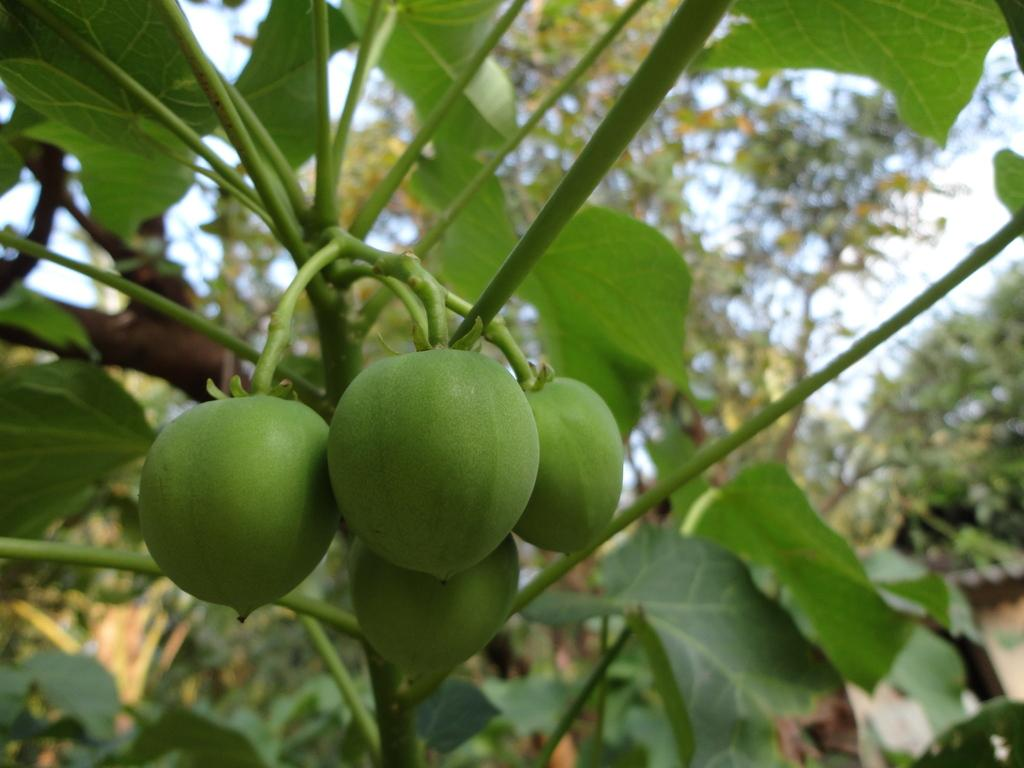What type of living organisms can be seen on the plant in the image? There are fruits on a plant in the image. What can be seen in the background of the image? There are trees in the background of the image. How many dinosaurs can be seen grazing on the fruits in the image? There are no dinosaurs present in the image; it features a plant with fruits and trees in the background. 